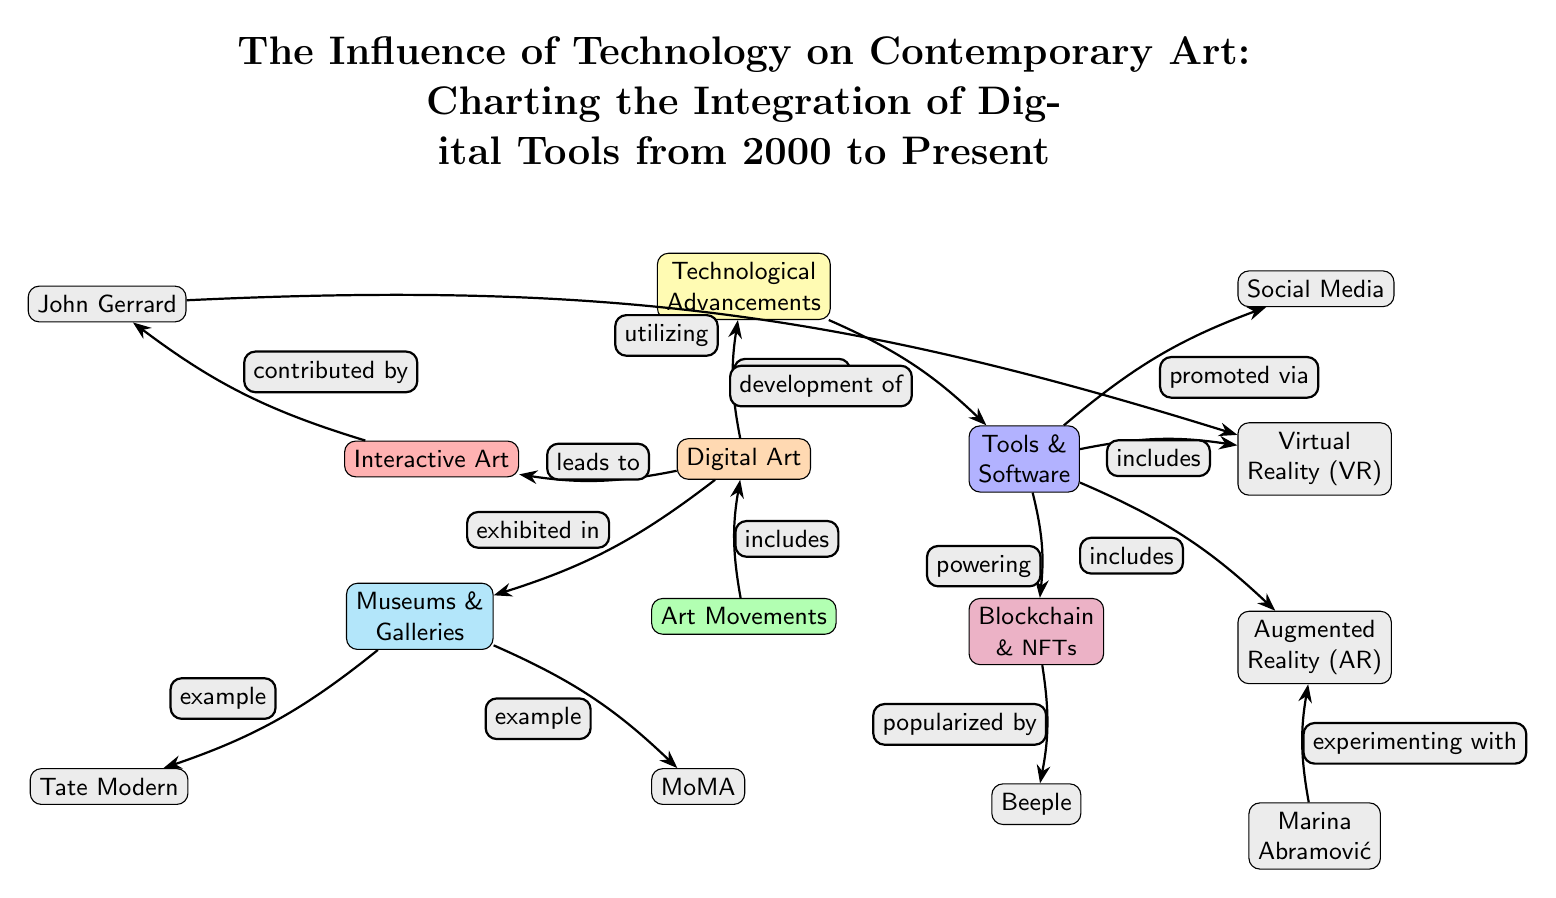What is the title of the diagram? The title is explicitly stated at the top of the diagram and reads: "The Influence of Technology on Contemporary Art: Charting the Integration of Digital Tools from 2000 to Present."
Answer: The Influence of Technology on Contemporary Art: Charting the Integration of Digital Tools from 2000 to Present How many main nodes are in the diagram? By counting the main nodes or categories in the diagram, we recognize nodes like Digital Art, Technological Advancements, Tools & Software, Art Movements, Interactive Art, Blockchain & NFTs, Museums & Galleries, and examples of museums which totals to 8.
Answer: 8 Which node is positioned above Digital Art? The node directly above Digital Art is Technological Advancements, as visually it is located in the higher position in relation to Digital Art.
Answer: Technological Advancements What is the relationship between Tools & Software and Augmented Reality? The relationship is depicted by an arrow labeled "includes," indicating that Tools & Software encompasses Augmented Reality as part of its components.
Answer: includes Who popularized Blockchain & NFTs according to the diagram? The diagram indicates that Beeple popularized Blockchain & NFTs, as represented by the arrow directed from Blockchain & NFTs to Beeple with the label "popularized by."
Answer: Beeple How does Digital Art relate to Museums & Galleries? The diagram illustrates that Digital Art is exhibited in Museums & Galleries, as denoted by the arrow labeled "exhibited in" pointing towards Museums & Galleries from Digital Art.
Answer: exhibited in Which artist is connected to the node for Interactive Art? The node connected to Interactive Art is John Gerrard, according to the arrow labeled "contributed by" that directs from Interactive Art to John Gerrard.
Answer: John Gerrard What role does Social Media play in relation to Tools & Software? Social Media is defined as being promoted via Tools & Software, indicated by the arrow that leads from Tools & Software to Social Media, labeled "promoted via."
Answer: promoted via In which two museums is Digital Art exhibited according to the diagram? The diagram lists two museums, specifically Tate Modern and MoMA, as examples where Digital Art is exhibited, following arrows labeled "example."
Answer: Tate Modern, MoMA 